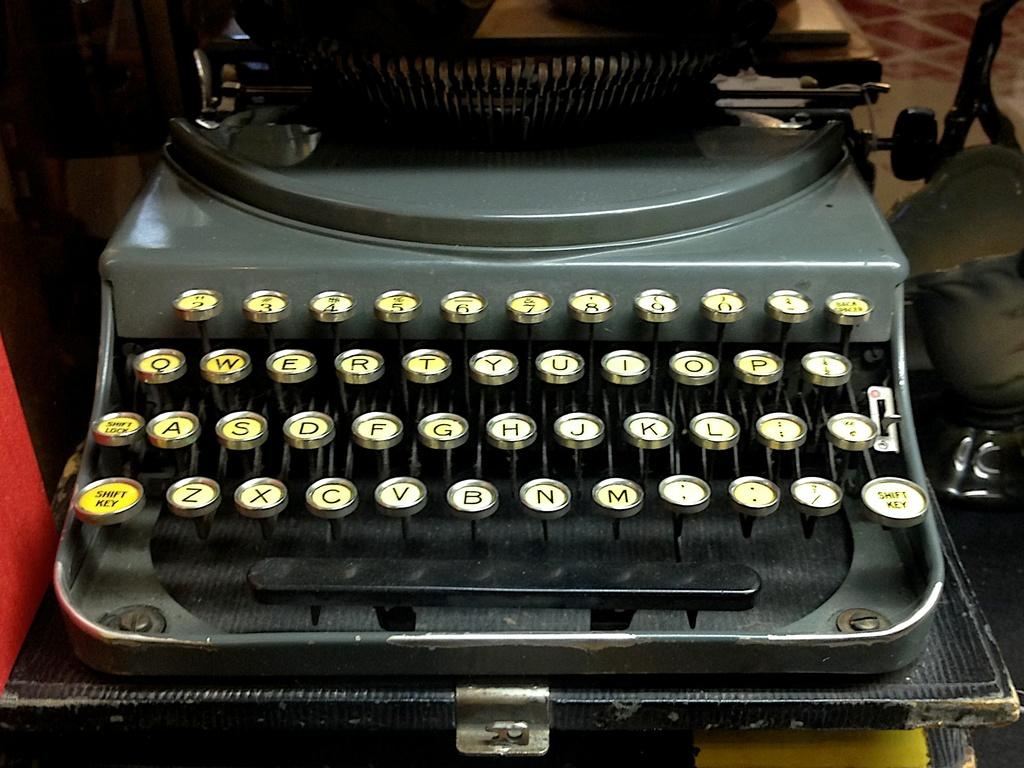<image>
Render a clear and concise summary of the photo. a typewriter with a key that says 'shift key' on it 